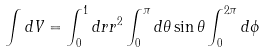Convert formula to latex. <formula><loc_0><loc_0><loc_500><loc_500>\int d V = \int ^ { 1 } _ { 0 } d r r ^ { 2 } \int ^ { \pi } _ { 0 } d \theta \sin { \theta } \int ^ { 2 \pi } _ { 0 } d \phi \,</formula> 